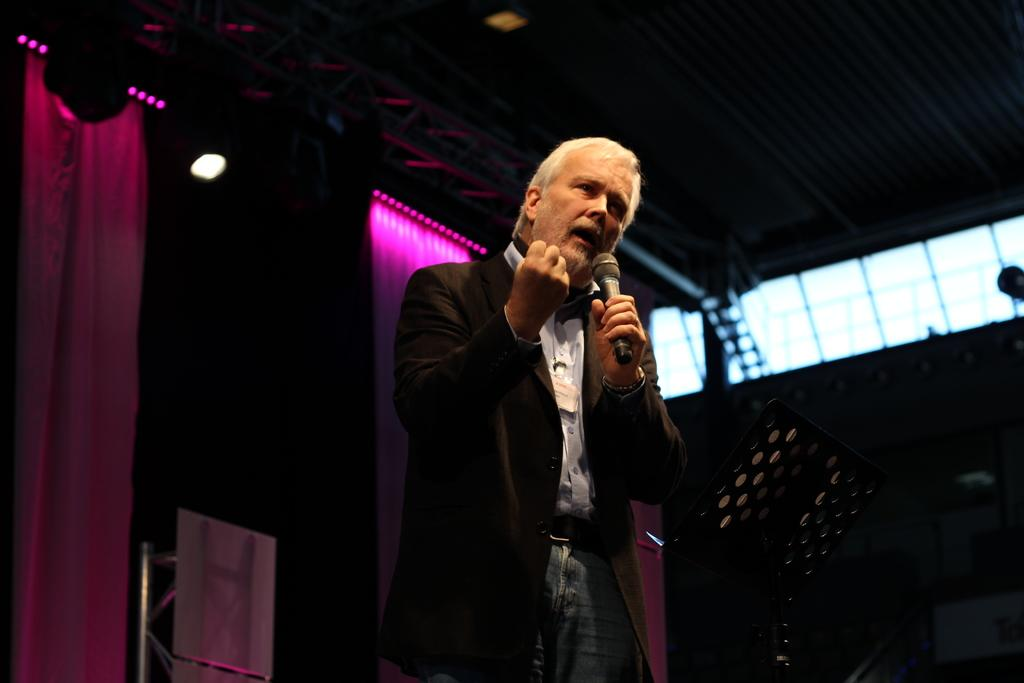What is the man in the image wearing? The man is wearing a suit and a white shirt. What is the man holding in his hand? The man is holding a microphone in his hand. What is the man doing in the image? The man is speaking. What can be seen in the background of the image? There is a curtain, a light, and a stand in the background of the image. How does the man balance his income in the image? There is no information about the man's income in the image. --- Facts: 1. There is a car in the image. 2. The car is red. 3. The car has four wheels. 4. The car has a sunroof. 5. The car has a license plate. 6. The car is parked on the street. Absurd Topics: rainbow Conversation: What type of vehicle is in the image? There is a car in the image. What color is the car? The car is red. How many wheels does the car have? The car has four wheels. What special feature does the car have? The car has a sunroof. Where is the car located in the image? The car is parked on the street. Reasoning: Let's think step by step in order to produce the conversation. We start by identifying the main subject in the image, which is the car. Then, we describe specific features of the car, such as its color, the number of wheels it has, and any special features it might have. Next, we observe the car's location in the image. Finally, we ensure that the language is simple and clear. Absurd Question/Answer: Can you see a rainbow in the image? There is no rainbow present in the image. 